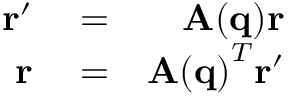Convert formula to latex. <formula><loc_0><loc_0><loc_500><loc_500>\begin{array} { r l r } { r { ^ { \prime } } } & = } & { A ( q ) r } \\ { r } & = } & { A ( q ) ^ { T } r { ^ { \prime } } } \end{array}</formula> 